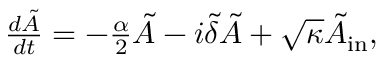<formula> <loc_0><loc_0><loc_500><loc_500>\begin{array} { r } { \frac { d \tilde { A } } { d t } = - \frac { \alpha } { 2 } \tilde { A } - i \tilde { \delta } \tilde { A } + \sqrt { \kappa } \tilde { A } _ { i n } , } \end{array}</formula> 